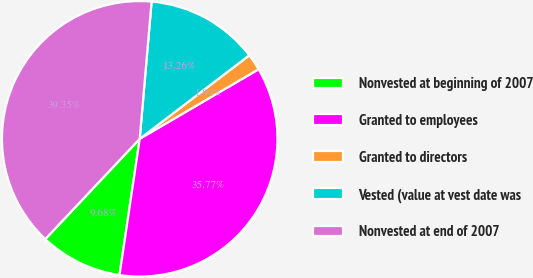Convert chart. <chart><loc_0><loc_0><loc_500><loc_500><pie_chart><fcel>Nonvested at beginning of 2007<fcel>Granted to employees<fcel>Granted to directors<fcel>Vested (value at vest date was<fcel>Nonvested at end of 2007<nl><fcel>9.68%<fcel>35.77%<fcel>1.94%<fcel>13.26%<fcel>39.35%<nl></chart> 